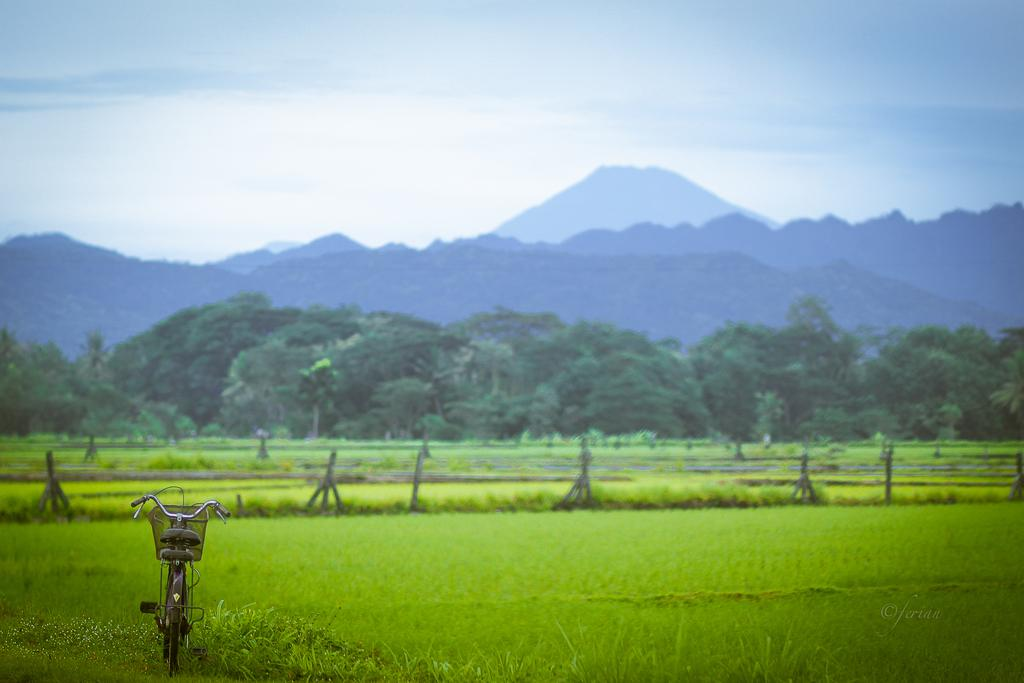What is the main object in the image? There is a bicycle in the image. Where is the bicycle located? The bicycle is at the bottom side of the image. What type of environment is depicted? There is greenery in the image. How many roots can be seen growing from the bicycle in the image? There are no roots growing from the bicycle in the image. Is the bicycle sleeping in the image? Bicycles do not sleep, so this question is not applicable. 